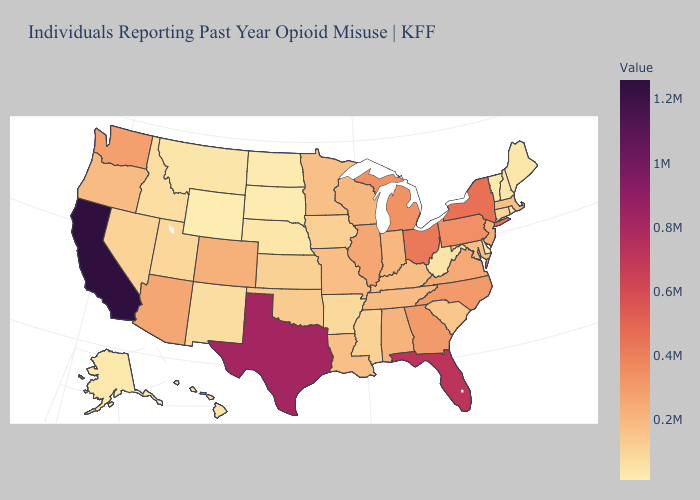Among the states that border Rhode Island , which have the lowest value?
Keep it brief. Connecticut. Which states have the highest value in the USA?
Write a very short answer. California. Which states have the lowest value in the Northeast?
Short answer required. Vermont. 